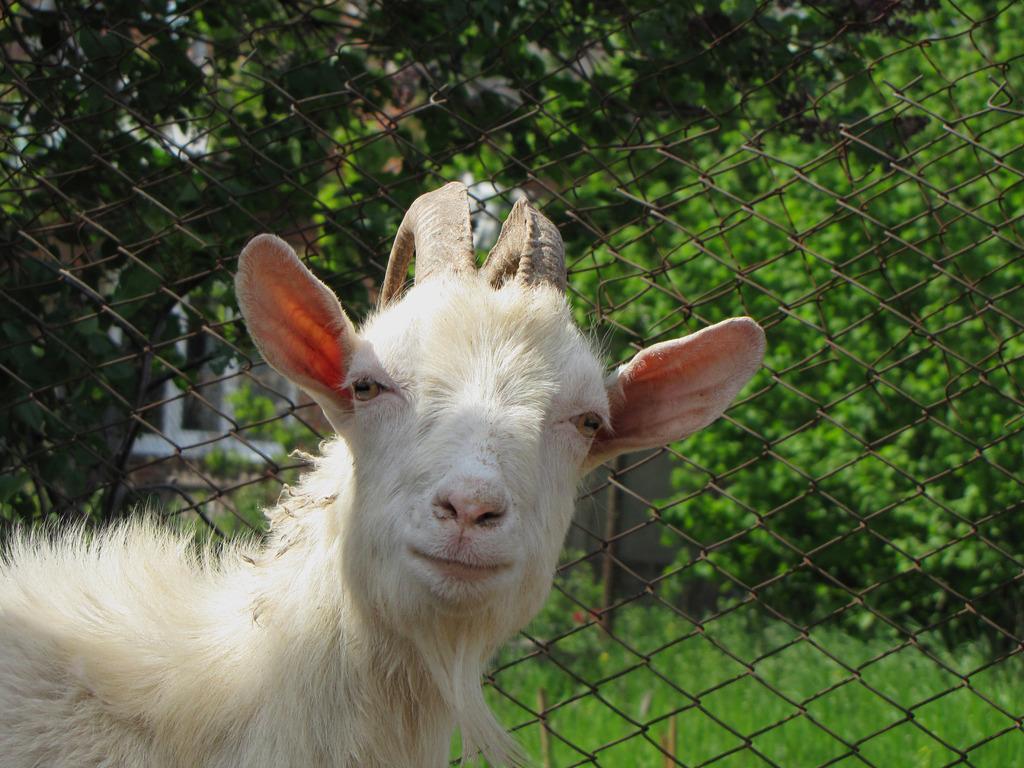Can you describe this image briefly? In this image we can see an animal. And we can see the metal fencing. And we can see the grass and trees. 